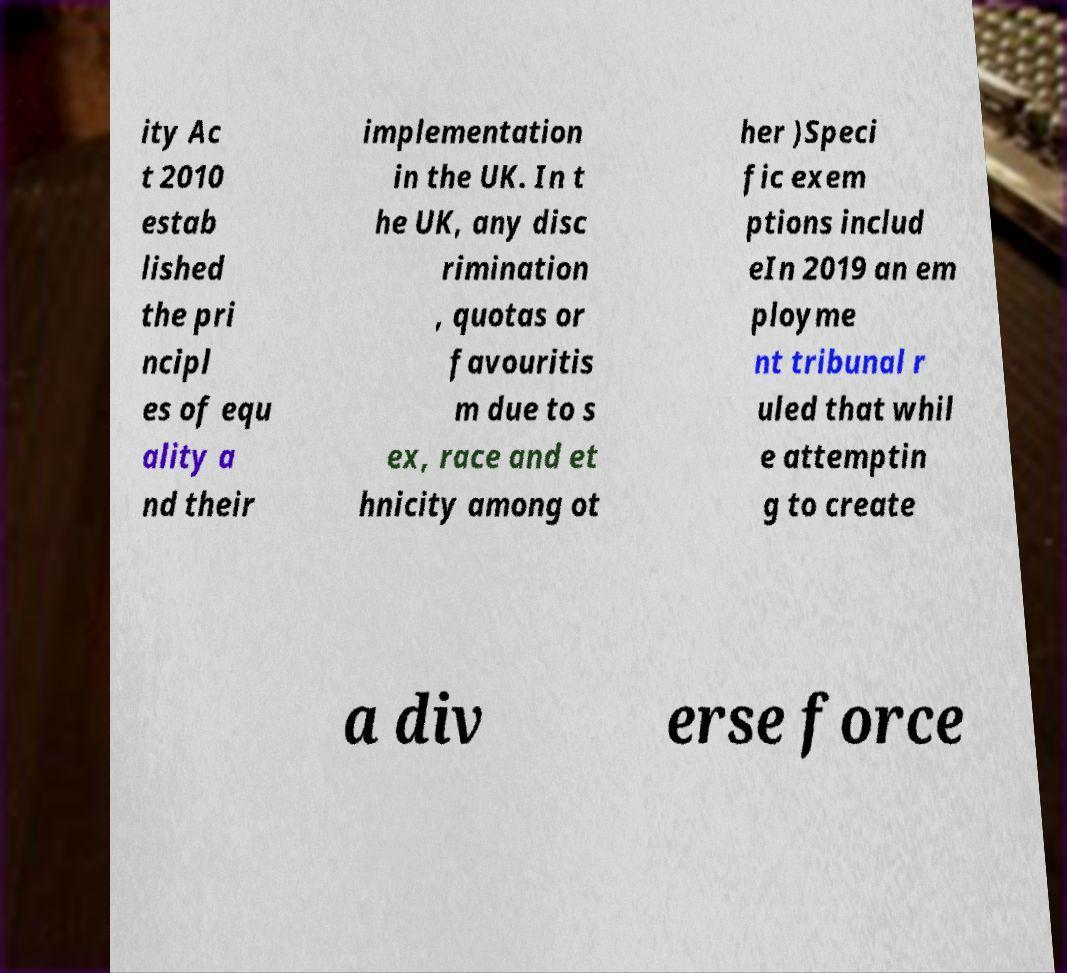What messages or text are displayed in this image? I need them in a readable, typed format. ity Ac t 2010 estab lished the pri ncipl es of equ ality a nd their implementation in the UK. In t he UK, any disc rimination , quotas or favouritis m due to s ex, race and et hnicity among ot her )Speci fic exem ptions includ eIn 2019 an em ployme nt tribunal r uled that whil e attemptin g to create a div erse force 